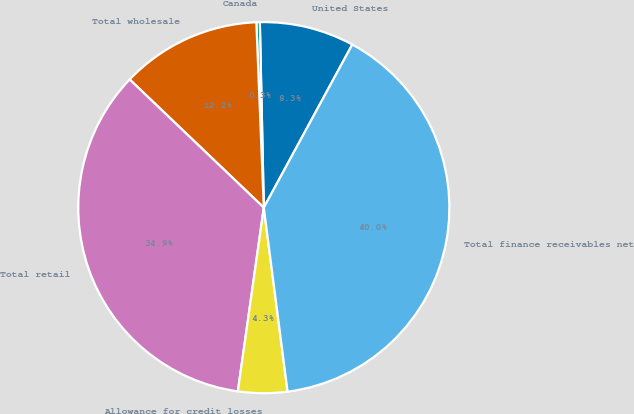<chart> <loc_0><loc_0><loc_500><loc_500><pie_chart><fcel>United States<fcel>Canada<fcel>Total wholesale<fcel>Total retail<fcel>Allowance for credit losses<fcel>Total finance receivables net<nl><fcel>8.25%<fcel>0.3%<fcel>12.22%<fcel>34.9%<fcel>4.28%<fcel>40.04%<nl></chart> 